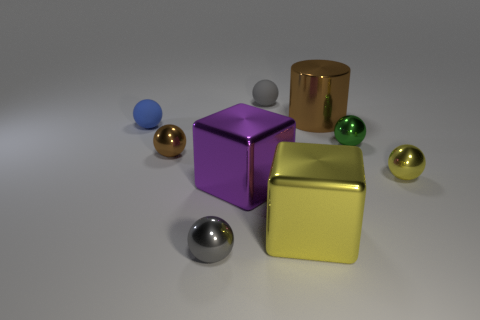Subtract all yellow balls. How many balls are left? 5 Subtract all brown metal spheres. How many spheres are left? 5 Subtract all blue balls. Subtract all cyan cylinders. How many balls are left? 5 Add 1 small metallic balls. How many objects exist? 10 Subtract all spheres. How many objects are left? 3 Add 7 large cyan metallic cylinders. How many large cyan metallic cylinders exist? 7 Subtract 1 brown balls. How many objects are left? 8 Subtract all purple cubes. Subtract all small gray matte things. How many objects are left? 7 Add 3 gray balls. How many gray balls are left? 5 